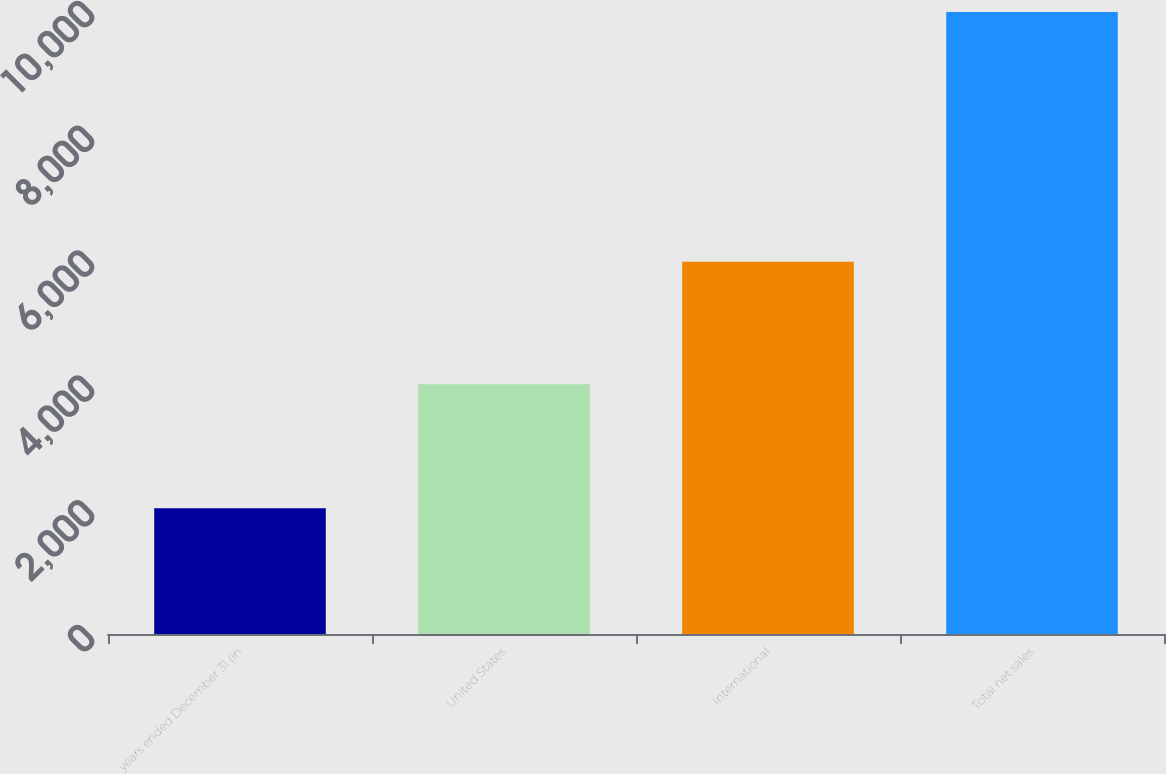Convert chart. <chart><loc_0><loc_0><loc_500><loc_500><bar_chart><fcel>years ended December 31 (in<fcel>United States<fcel>International<fcel>Total net sales<nl><fcel>2015<fcel>4001<fcel>5967<fcel>9968<nl></chart> 